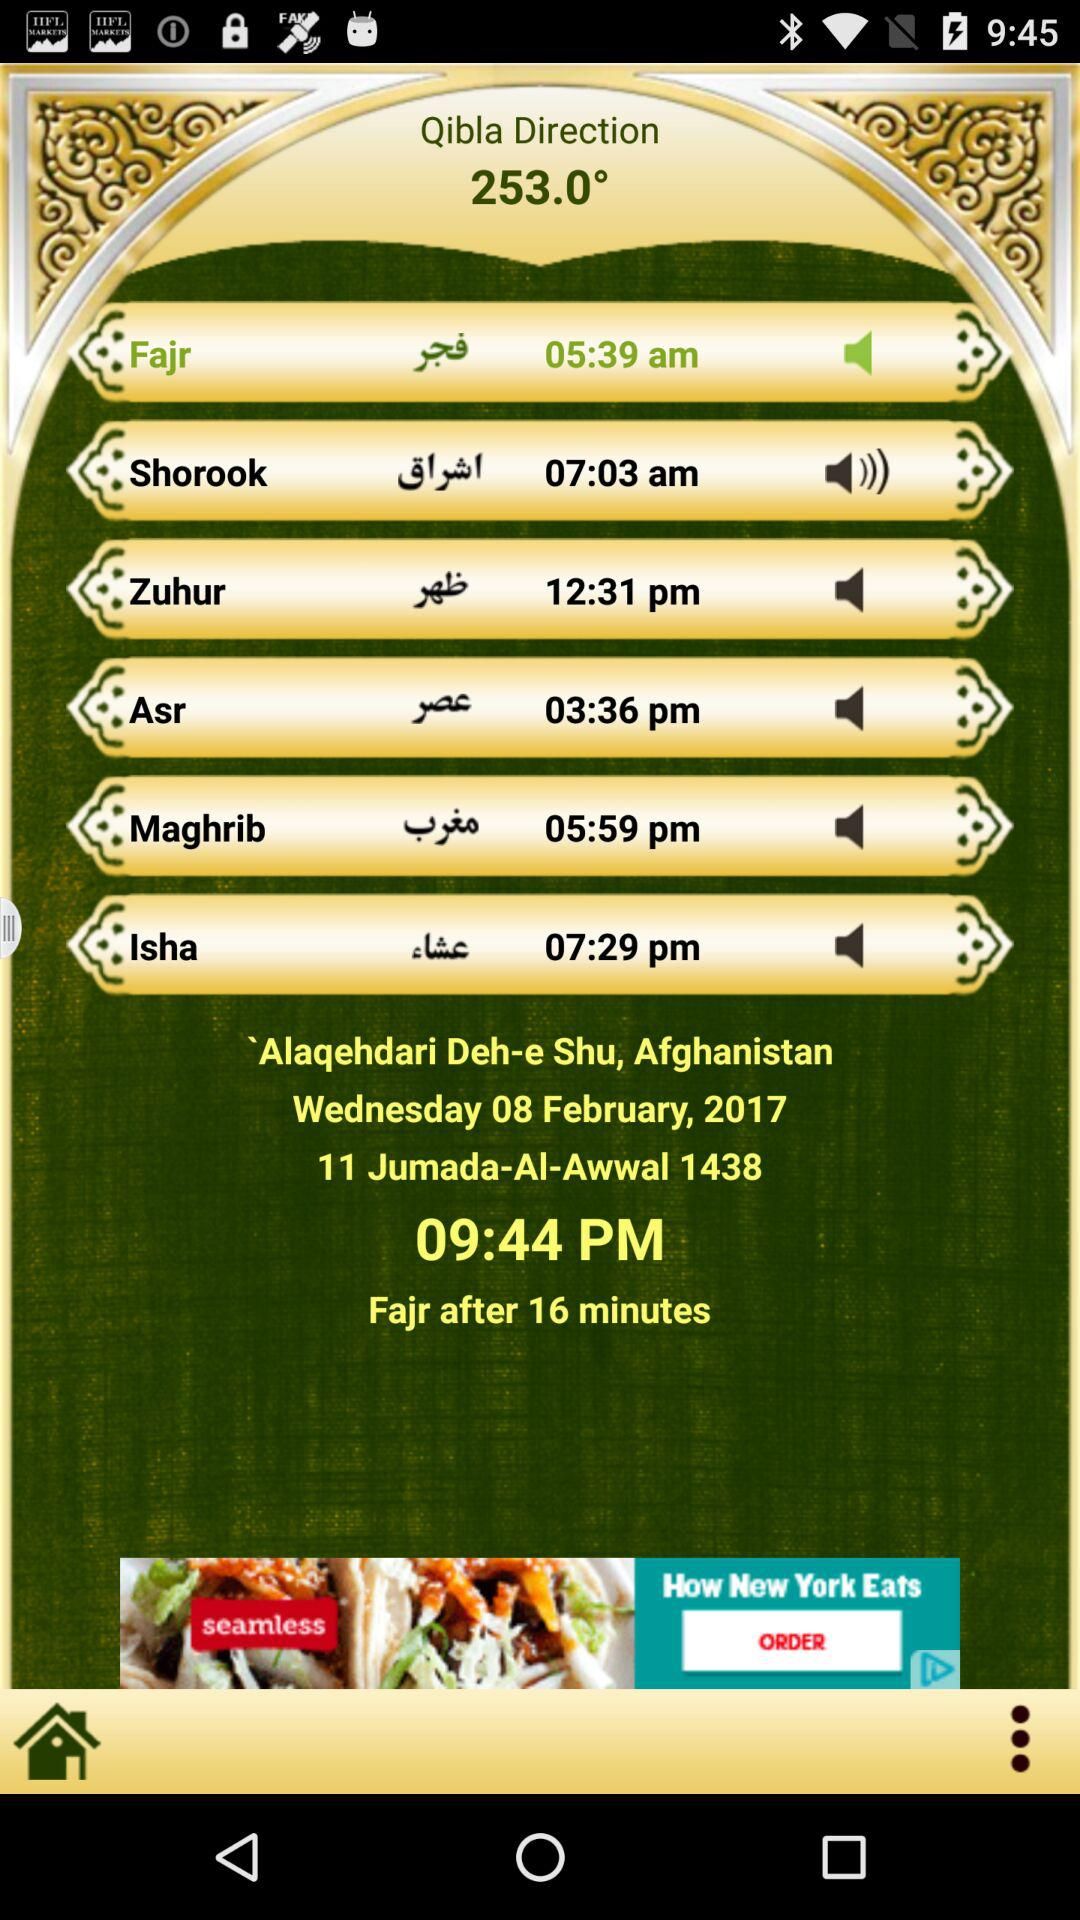What's the time for "Asr"? The time is 03:36 PM. 